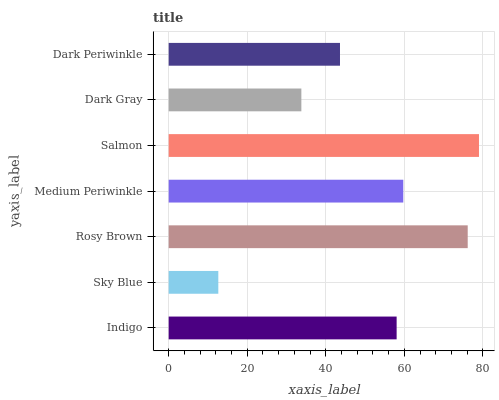Is Sky Blue the minimum?
Answer yes or no. Yes. Is Salmon the maximum?
Answer yes or no. Yes. Is Rosy Brown the minimum?
Answer yes or no. No. Is Rosy Brown the maximum?
Answer yes or no. No. Is Rosy Brown greater than Sky Blue?
Answer yes or no. Yes. Is Sky Blue less than Rosy Brown?
Answer yes or no. Yes. Is Sky Blue greater than Rosy Brown?
Answer yes or no. No. Is Rosy Brown less than Sky Blue?
Answer yes or no. No. Is Indigo the high median?
Answer yes or no. Yes. Is Indigo the low median?
Answer yes or no. Yes. Is Salmon the high median?
Answer yes or no. No. Is Sky Blue the low median?
Answer yes or no. No. 